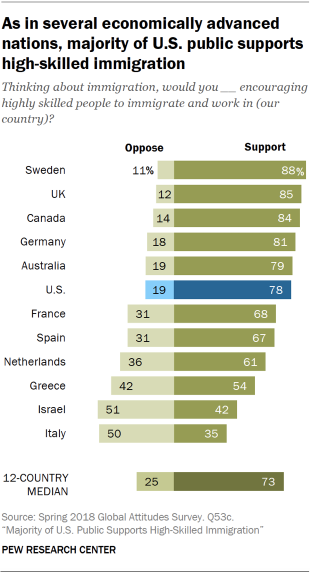Give some essential details in this illustration. The value of a navy blue bar is 78. 